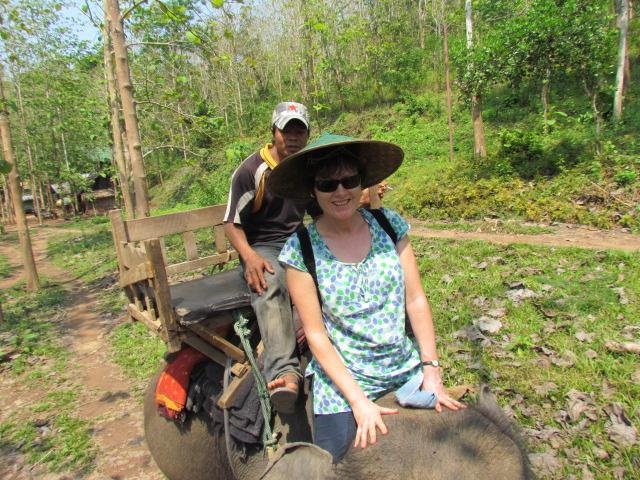Who is guiding the elephant?

Choices:
A) man
B) cat
C) woman
D) nobody man 